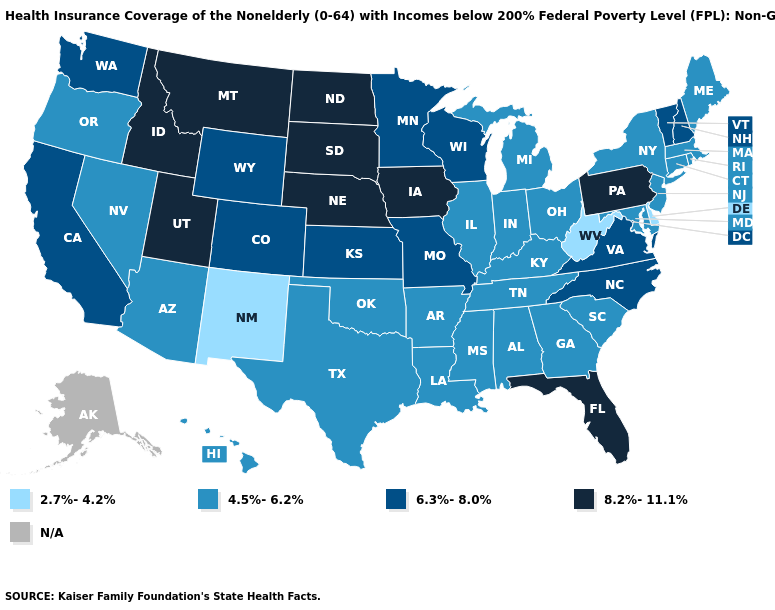What is the highest value in the USA?
Keep it brief. 8.2%-11.1%. What is the lowest value in the USA?
Write a very short answer. 2.7%-4.2%. What is the highest value in states that border Montana?
Keep it brief. 8.2%-11.1%. What is the value of Wyoming?
Keep it brief. 6.3%-8.0%. Name the states that have a value in the range 6.3%-8.0%?
Concise answer only. California, Colorado, Kansas, Minnesota, Missouri, New Hampshire, North Carolina, Vermont, Virginia, Washington, Wisconsin, Wyoming. Does the map have missing data?
Keep it brief. Yes. Which states have the lowest value in the USA?
Be succinct. Delaware, New Mexico, West Virginia. What is the value of New York?
Concise answer only. 4.5%-6.2%. What is the lowest value in the West?
Write a very short answer. 2.7%-4.2%. What is the highest value in the USA?
Quick response, please. 8.2%-11.1%. How many symbols are there in the legend?
Keep it brief. 5. What is the value of Alabama?
Concise answer only. 4.5%-6.2%. Name the states that have a value in the range N/A?
Answer briefly. Alaska. 